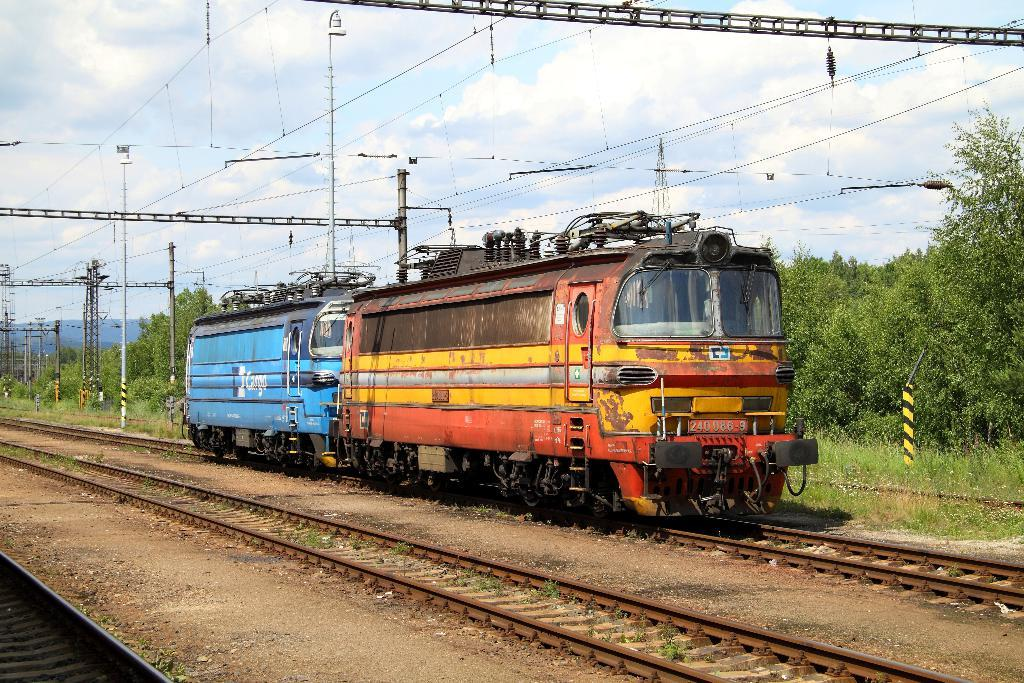What can be seen on one of the tracks in the image? There is a train engine on one of the tracks. What infrastructure elements are present in the image? Electric poles and cables can be seen in the image. What type of vegetation is visible in the image? There are trees and plants in the image. What is visible in the sky in the image? There are clouds in the sky. How many bears can be seen learning to play the guitar in the image? There are no bears or guitars present in the image. 